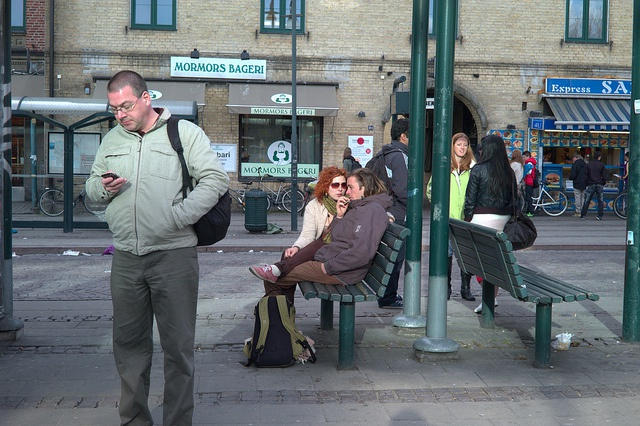Describe the objects in this image and their specific colors. I can see people in gray, darkgray, black, and lightgray tones, people in gray, black, and maroon tones, bench in gray, black, purple, and darkgray tones, bench in gray, black, purple, and darkblue tones, and people in gray, black, white, and purple tones in this image. 